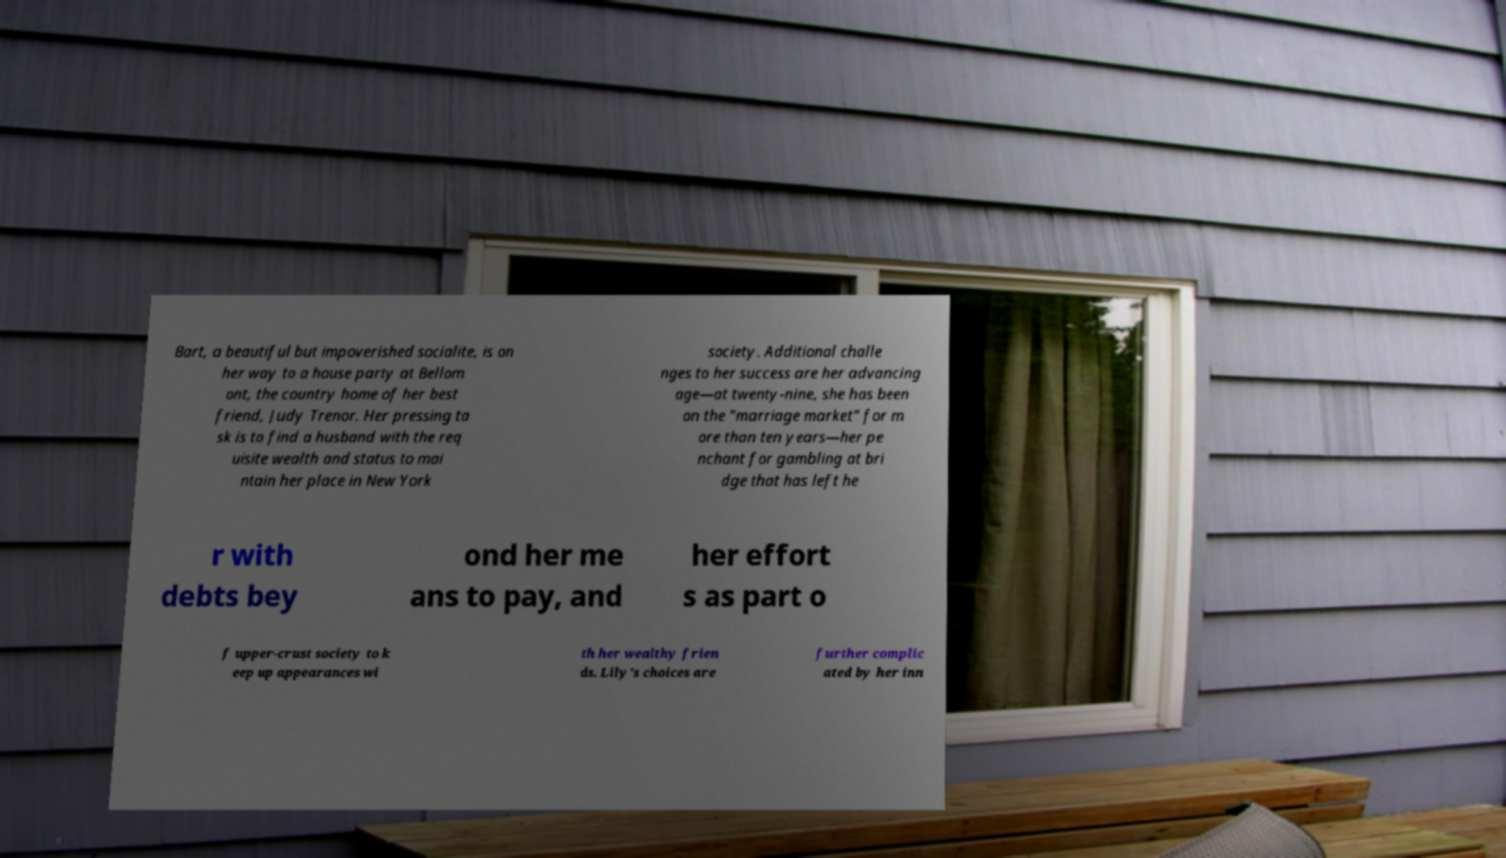Please read and relay the text visible in this image. What does it say? Bart, a beautiful but impoverished socialite, is on her way to a house party at Bellom ont, the country home of her best friend, Judy Trenor. Her pressing ta sk is to find a husband with the req uisite wealth and status to mai ntain her place in New York society. Additional challe nges to her success are her advancing age—at twenty-nine, she has been on the "marriage market" for m ore than ten years—her pe nchant for gambling at bri dge that has left he r with debts bey ond her me ans to pay, and her effort s as part o f upper-crust society to k eep up appearances wi th her wealthy frien ds. Lily's choices are further complic ated by her inn 